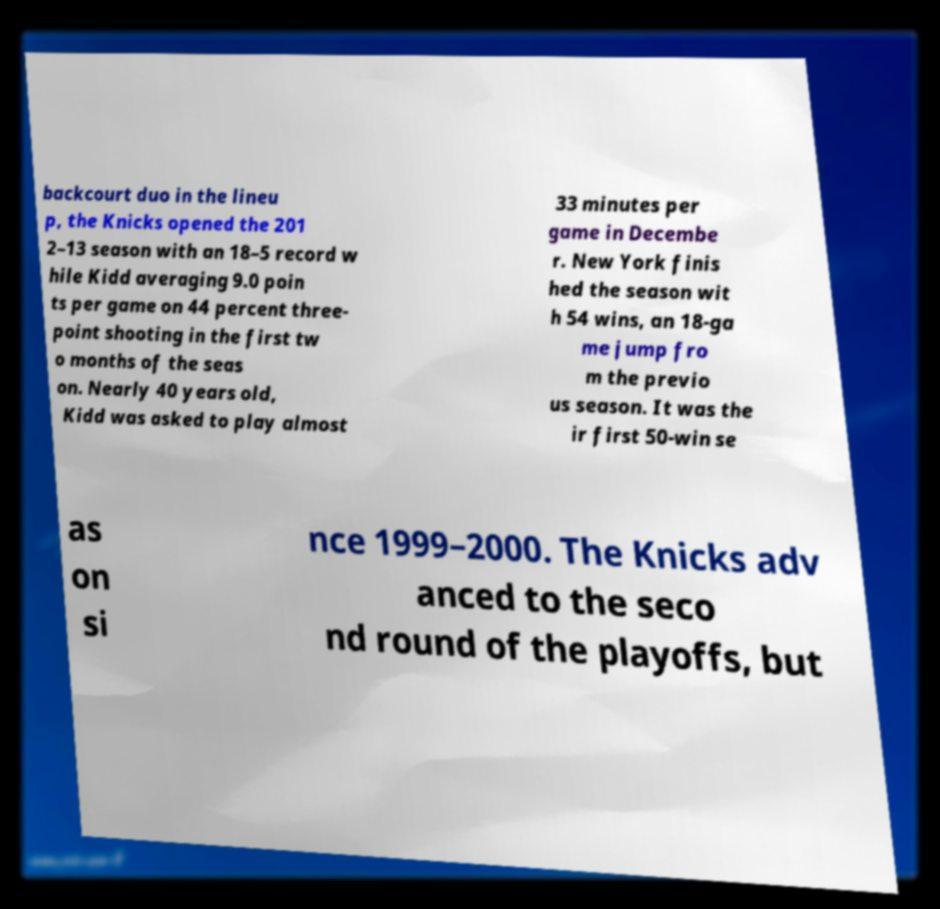For documentation purposes, I need the text within this image transcribed. Could you provide that? backcourt duo in the lineu p, the Knicks opened the 201 2–13 season with an 18–5 record w hile Kidd averaging 9.0 poin ts per game on 44 percent three- point shooting in the first tw o months of the seas on. Nearly 40 years old, Kidd was asked to play almost 33 minutes per game in Decembe r. New York finis hed the season wit h 54 wins, an 18-ga me jump fro m the previo us season. It was the ir first 50-win se as on si nce 1999–2000. The Knicks adv anced to the seco nd round of the playoffs, but 